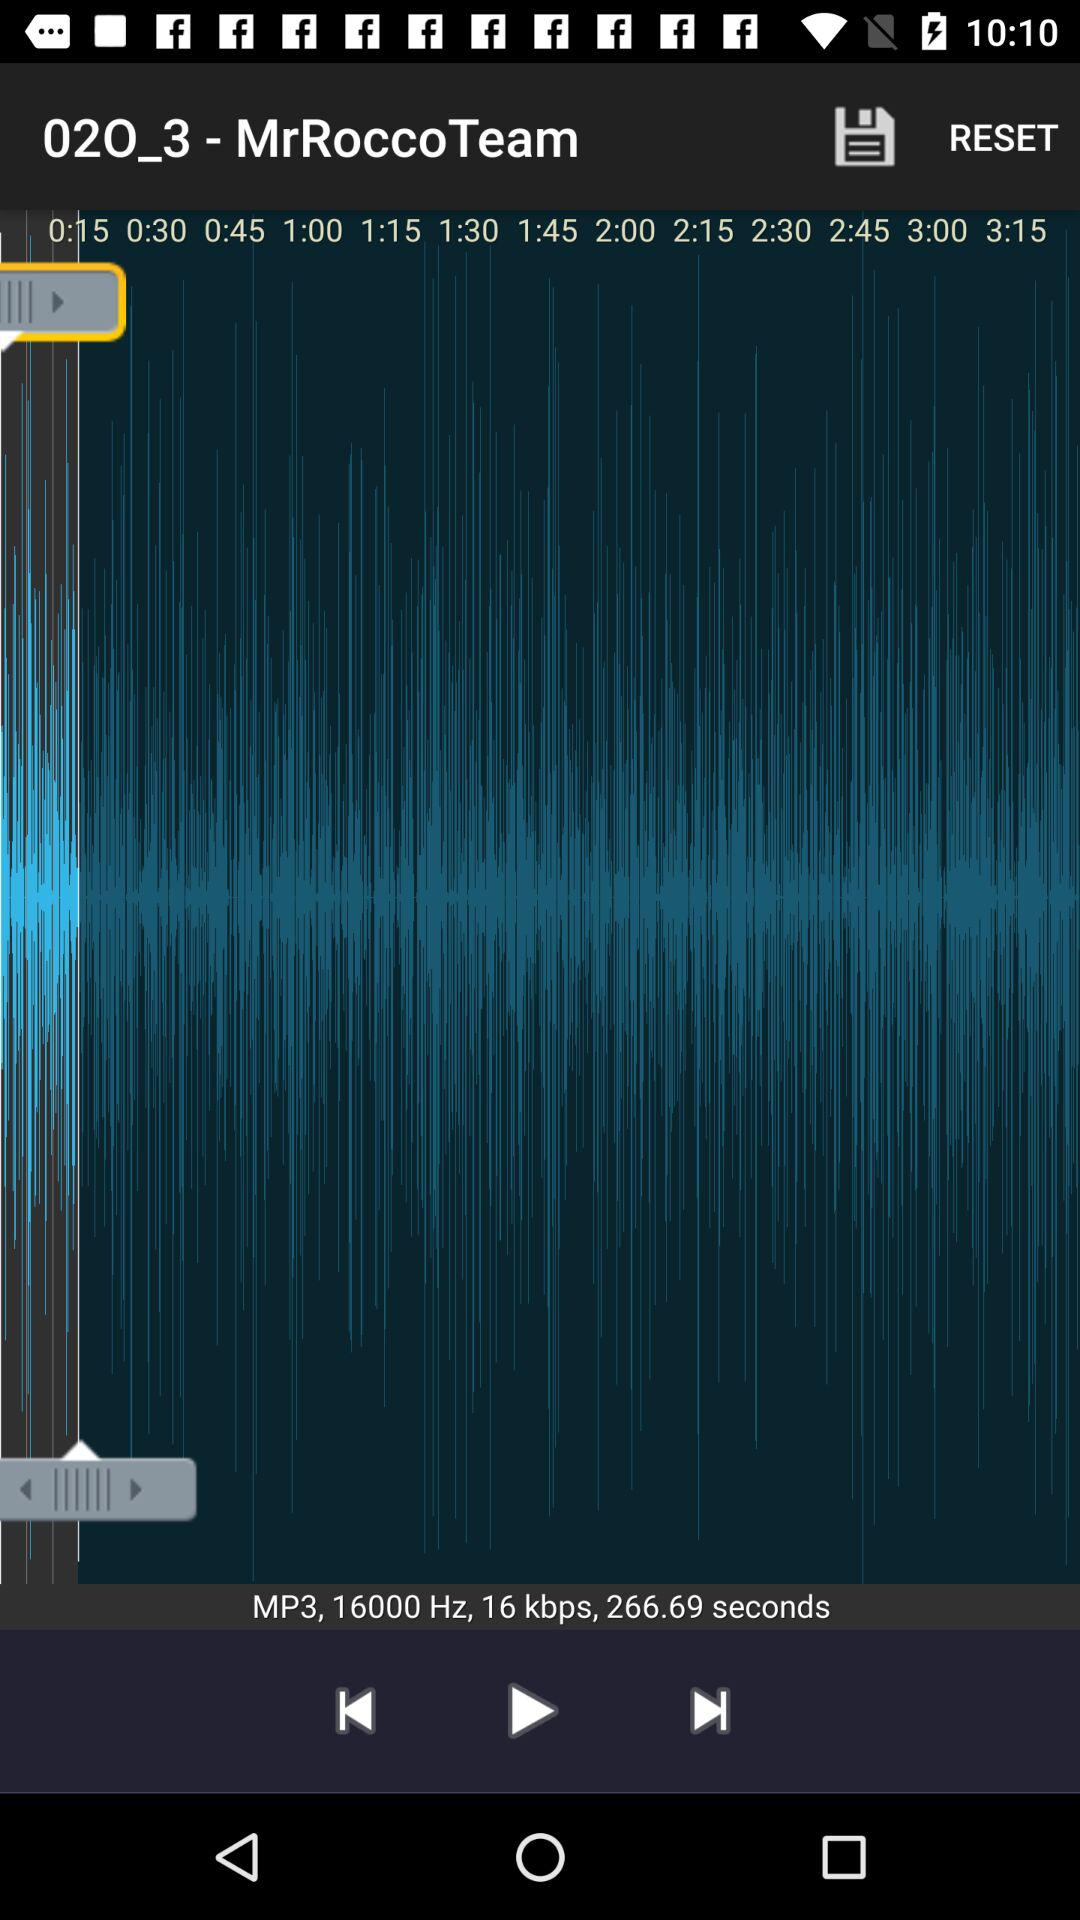How many seconds are there between the 1:15 and 2:00 marks?
Answer the question using a single word or phrase. 45 